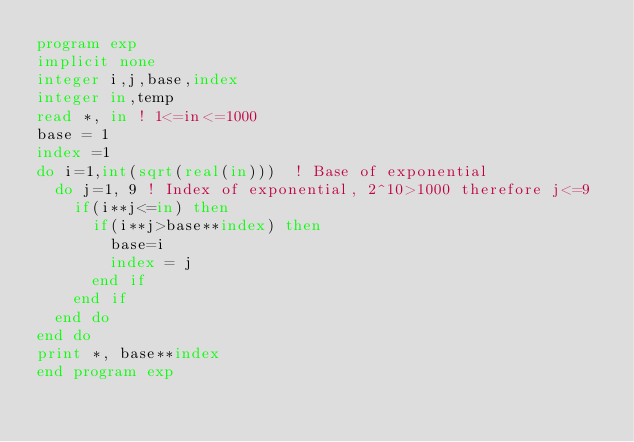<code> <loc_0><loc_0><loc_500><loc_500><_FORTRAN_>program exp
implicit none
integer i,j,base,index
integer in,temp
read *, in ! 1<=in<=1000
base = 1
index =1
do i=1,int(sqrt(real(in)))  ! Base of exponential
  do j=1, 9 ! Index of exponential, 2^10>1000 therefore j<=9
    if(i**j<=in) then
      if(i**j>base**index) then
        base=i
        index = j
      end if
    end if
  end do
end do
print *, base**index
end program exp</code> 